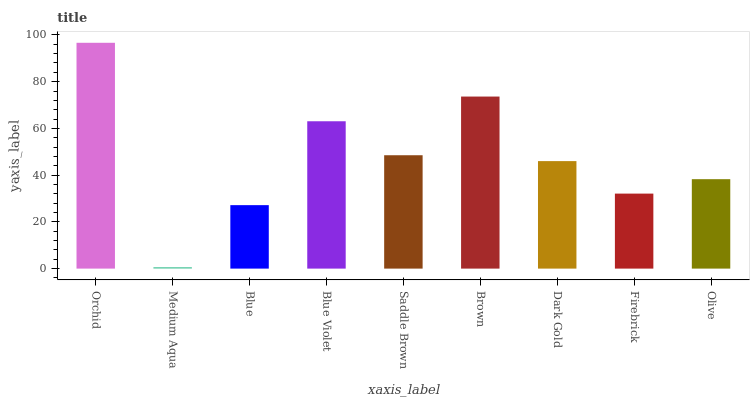Is Medium Aqua the minimum?
Answer yes or no. Yes. Is Orchid the maximum?
Answer yes or no. Yes. Is Blue the minimum?
Answer yes or no. No. Is Blue the maximum?
Answer yes or no. No. Is Blue greater than Medium Aqua?
Answer yes or no. Yes. Is Medium Aqua less than Blue?
Answer yes or no. Yes. Is Medium Aqua greater than Blue?
Answer yes or no. No. Is Blue less than Medium Aqua?
Answer yes or no. No. Is Dark Gold the high median?
Answer yes or no. Yes. Is Dark Gold the low median?
Answer yes or no. Yes. Is Blue Violet the high median?
Answer yes or no. No. Is Blue the low median?
Answer yes or no. No. 